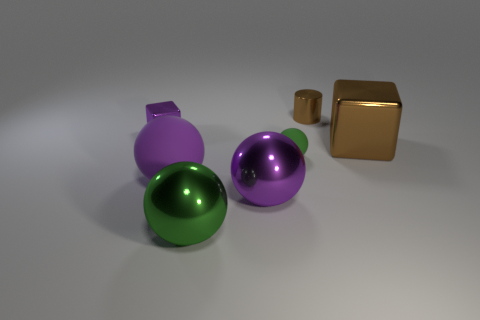How many green spheres must be subtracted to get 1 green spheres? 1 Subtract all spheres. How many objects are left? 3 Subtract 2 cubes. How many cubes are left? 0 Subtract all yellow blocks. Subtract all purple cylinders. How many blocks are left? 2 Subtract all green blocks. How many yellow balls are left? 0 Subtract all large cyan cylinders. Subtract all small balls. How many objects are left? 6 Add 7 large green spheres. How many large green spheres are left? 8 Add 7 big brown shiny things. How many big brown shiny things exist? 8 Add 1 green metal spheres. How many objects exist? 8 Subtract all brown cubes. How many cubes are left? 1 